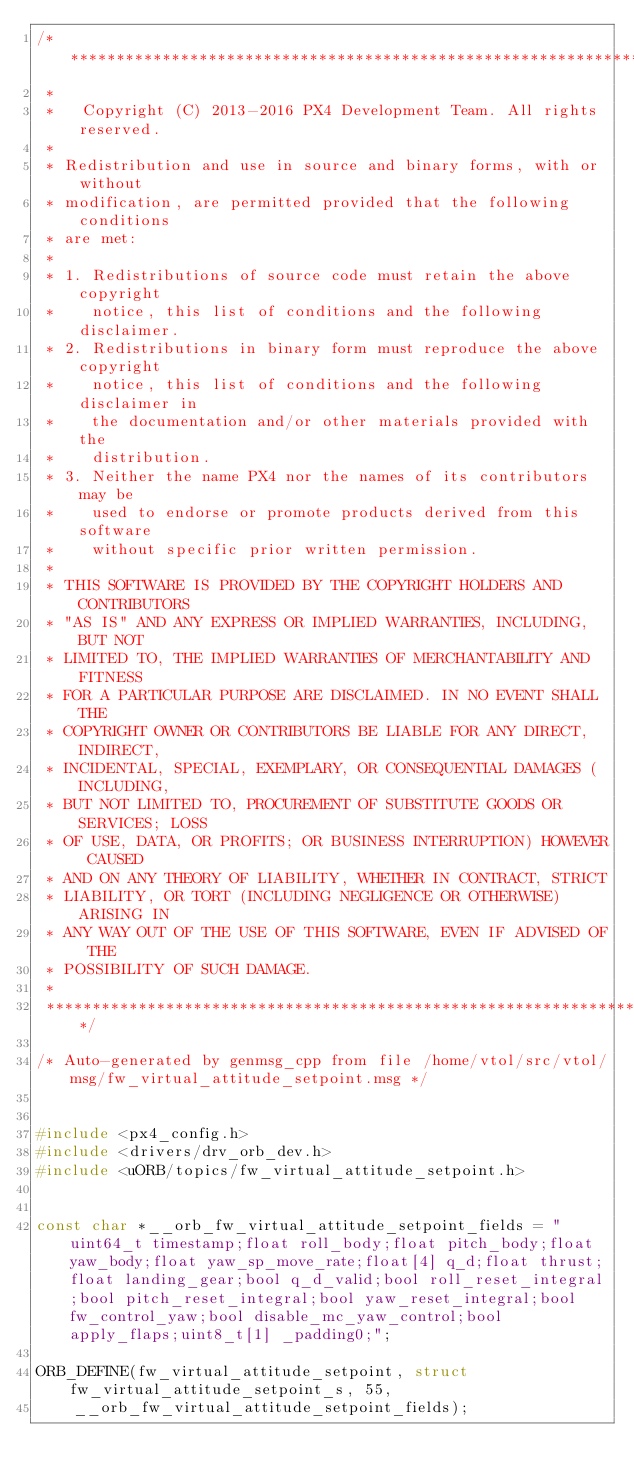Convert code to text. <code><loc_0><loc_0><loc_500><loc_500><_C++_>/****************************************************************************
 *
 *   Copyright (C) 2013-2016 PX4 Development Team. All rights reserved.
 *
 * Redistribution and use in source and binary forms, with or without
 * modification, are permitted provided that the following conditions
 * are met:
 *
 * 1. Redistributions of source code must retain the above copyright
 *    notice, this list of conditions and the following disclaimer.
 * 2. Redistributions in binary form must reproduce the above copyright
 *    notice, this list of conditions and the following disclaimer in
 *    the documentation and/or other materials provided with the
 *    distribution.
 * 3. Neither the name PX4 nor the names of its contributors may be
 *    used to endorse or promote products derived from this software
 *    without specific prior written permission.
 *
 * THIS SOFTWARE IS PROVIDED BY THE COPYRIGHT HOLDERS AND CONTRIBUTORS
 * "AS IS" AND ANY EXPRESS OR IMPLIED WARRANTIES, INCLUDING, BUT NOT
 * LIMITED TO, THE IMPLIED WARRANTIES OF MERCHANTABILITY AND FITNESS
 * FOR A PARTICULAR PURPOSE ARE DISCLAIMED. IN NO EVENT SHALL THE
 * COPYRIGHT OWNER OR CONTRIBUTORS BE LIABLE FOR ANY DIRECT, INDIRECT,
 * INCIDENTAL, SPECIAL, EXEMPLARY, OR CONSEQUENTIAL DAMAGES (INCLUDING,
 * BUT NOT LIMITED TO, PROCUREMENT OF SUBSTITUTE GOODS OR SERVICES; LOSS
 * OF USE, DATA, OR PROFITS; OR BUSINESS INTERRUPTION) HOWEVER CAUSED
 * AND ON ANY THEORY OF LIABILITY, WHETHER IN CONTRACT, STRICT
 * LIABILITY, OR TORT (INCLUDING NEGLIGENCE OR OTHERWISE) ARISING IN
 * ANY WAY OUT OF THE USE OF THIS SOFTWARE, EVEN IF ADVISED OF THE
 * POSSIBILITY OF SUCH DAMAGE.
 *
 ****************************************************************************/

/* Auto-generated by genmsg_cpp from file /home/vtol/src/vtol/msg/fw_virtual_attitude_setpoint.msg */


#include <px4_config.h>
#include <drivers/drv_orb_dev.h>
#include <uORB/topics/fw_virtual_attitude_setpoint.h>


const char *__orb_fw_virtual_attitude_setpoint_fields = "uint64_t timestamp;float roll_body;float pitch_body;float yaw_body;float yaw_sp_move_rate;float[4] q_d;float thrust;float landing_gear;bool q_d_valid;bool roll_reset_integral;bool pitch_reset_integral;bool yaw_reset_integral;bool fw_control_yaw;bool disable_mc_yaw_control;bool apply_flaps;uint8_t[1] _padding0;";

ORB_DEFINE(fw_virtual_attitude_setpoint, struct fw_virtual_attitude_setpoint_s, 55,
    __orb_fw_virtual_attitude_setpoint_fields);

</code> 